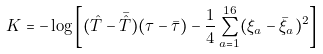Convert formula to latex. <formula><loc_0><loc_0><loc_500><loc_500>K = - \log \left [ ( \hat { T } - \bar { \hat { T } } ) ( \tau - \bar { \tau } ) - \frac { 1 } { 4 } \sum _ { a = 1 } ^ { 1 6 } ( \xi _ { a } - \bar { \xi } _ { a } ) ^ { 2 } \right ]</formula> 